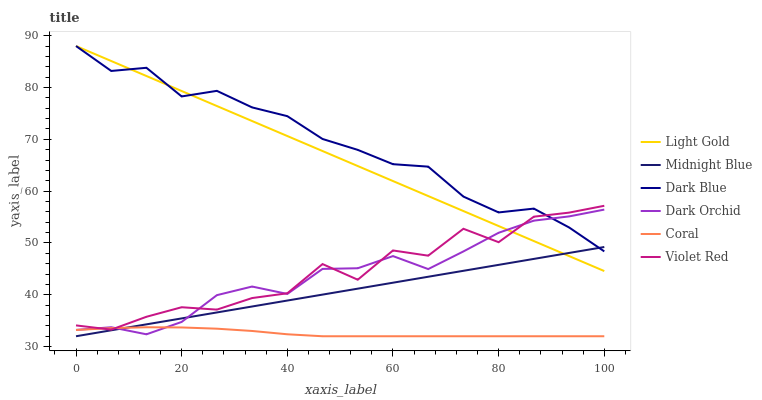Does Coral have the minimum area under the curve?
Answer yes or no. Yes. Does Dark Blue have the maximum area under the curve?
Answer yes or no. Yes. Does Midnight Blue have the minimum area under the curve?
Answer yes or no. No. Does Midnight Blue have the maximum area under the curve?
Answer yes or no. No. Is Midnight Blue the smoothest?
Answer yes or no. Yes. Is Violet Red the roughest?
Answer yes or no. Yes. Is Coral the smoothest?
Answer yes or no. No. Is Coral the roughest?
Answer yes or no. No. Does Midnight Blue have the lowest value?
Answer yes or no. Yes. Does Dark Orchid have the lowest value?
Answer yes or no. No. Does Light Gold have the highest value?
Answer yes or no. Yes. Does Midnight Blue have the highest value?
Answer yes or no. No. Is Midnight Blue less than Violet Red?
Answer yes or no. Yes. Is Light Gold greater than Coral?
Answer yes or no. Yes. Does Dark Orchid intersect Violet Red?
Answer yes or no. Yes. Is Dark Orchid less than Violet Red?
Answer yes or no. No. Is Dark Orchid greater than Violet Red?
Answer yes or no. No. Does Midnight Blue intersect Violet Red?
Answer yes or no. No. 